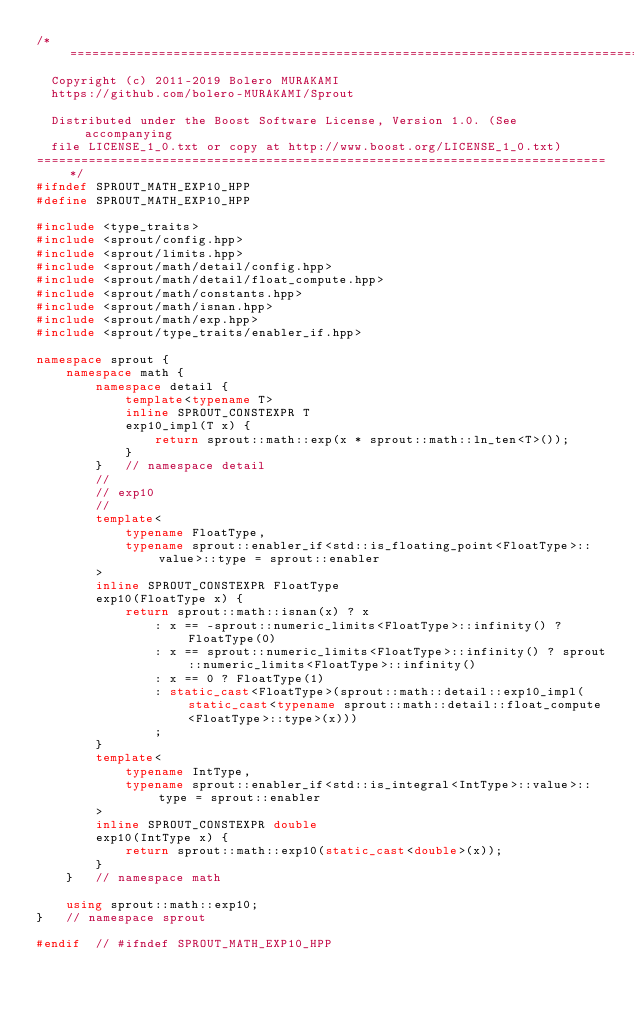<code> <loc_0><loc_0><loc_500><loc_500><_C++_>/*=============================================================================
  Copyright (c) 2011-2019 Bolero MURAKAMI
  https://github.com/bolero-MURAKAMI/Sprout

  Distributed under the Boost Software License, Version 1.0. (See accompanying
  file LICENSE_1_0.txt or copy at http://www.boost.org/LICENSE_1_0.txt)
=============================================================================*/
#ifndef SPROUT_MATH_EXP10_HPP
#define SPROUT_MATH_EXP10_HPP

#include <type_traits>
#include <sprout/config.hpp>
#include <sprout/limits.hpp>
#include <sprout/math/detail/config.hpp>
#include <sprout/math/detail/float_compute.hpp>
#include <sprout/math/constants.hpp>
#include <sprout/math/isnan.hpp>
#include <sprout/math/exp.hpp>
#include <sprout/type_traits/enabler_if.hpp>

namespace sprout {
	namespace math {
		namespace detail {
			template<typename T>
			inline SPROUT_CONSTEXPR T
			exp10_impl(T x) {
				return sprout::math::exp(x * sprout::math::ln_ten<T>());
			}
		}	// namespace detail
		//
		// exp10
		//
		template<
			typename FloatType,
			typename sprout::enabler_if<std::is_floating_point<FloatType>::value>::type = sprout::enabler
		>
		inline SPROUT_CONSTEXPR FloatType
		exp10(FloatType x) {
			return sprout::math::isnan(x) ? x
				: x == -sprout::numeric_limits<FloatType>::infinity() ? FloatType(0)
				: x == sprout::numeric_limits<FloatType>::infinity() ? sprout::numeric_limits<FloatType>::infinity()
				: x == 0 ? FloatType(1)
				: static_cast<FloatType>(sprout::math::detail::exp10_impl(static_cast<typename sprout::math::detail::float_compute<FloatType>::type>(x)))
				;
		}
		template<
			typename IntType,
			typename sprout::enabler_if<std::is_integral<IntType>::value>::type = sprout::enabler
		>
		inline SPROUT_CONSTEXPR double
		exp10(IntType x) {
			return sprout::math::exp10(static_cast<double>(x));
		}
	}	// namespace math

	using sprout::math::exp10;
}	// namespace sprout

#endif	// #ifndef SPROUT_MATH_EXP10_HPP
</code> 